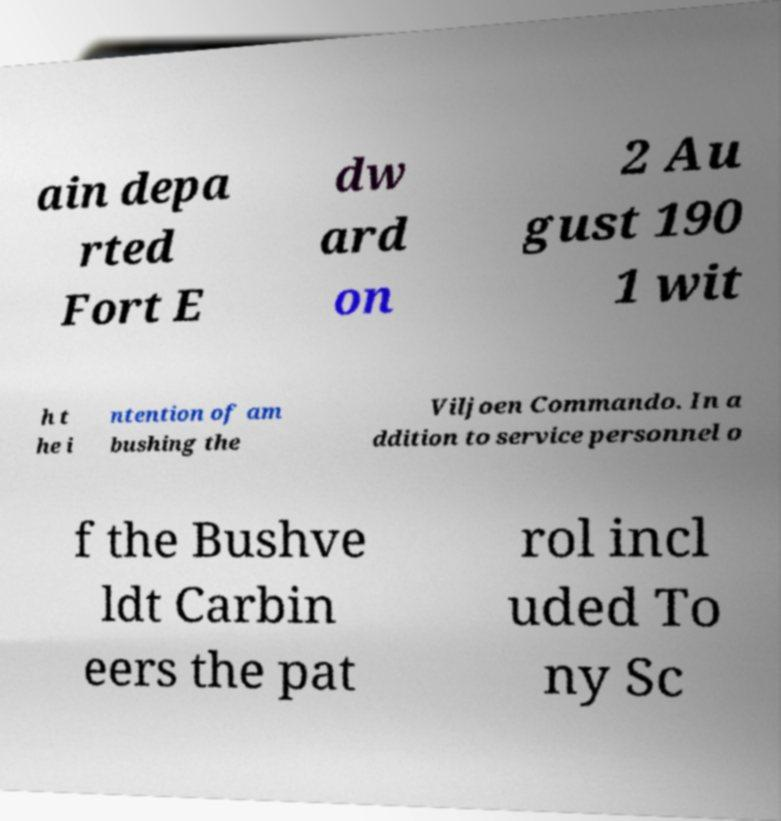Can you read and provide the text displayed in the image?This photo seems to have some interesting text. Can you extract and type it out for me? ain depa rted Fort E dw ard on 2 Au gust 190 1 wit h t he i ntention of am bushing the Viljoen Commando. In a ddition to service personnel o f the Bushve ldt Carbin eers the pat rol incl uded To ny Sc 